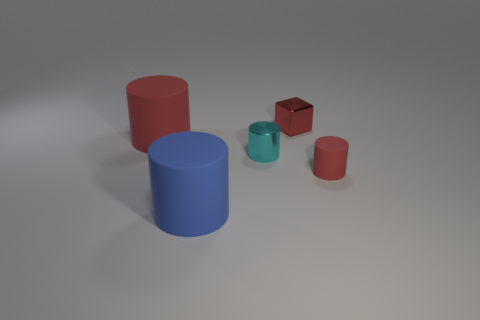What number of objects are either tiny cylinders that are to the right of the shiny block or small green objects?
Provide a succinct answer. 1. Is the number of large rubber objects that are behind the blue cylinder greater than the number of cyan shiny cylinders that are behind the metallic cylinder?
Provide a succinct answer. Yes. There is a matte cylinder that is the same color as the tiny matte thing; what is its size?
Provide a short and direct response. Large. There is a cube; is it the same size as the red thing right of the small red block?
Offer a very short reply. Yes. How many cylinders are either blue rubber objects or small objects?
Give a very brief answer. 3. What is the size of the red block that is made of the same material as the cyan cylinder?
Make the answer very short. Small. There is a red rubber cylinder on the right side of the blue rubber cylinder; does it have the same size as the red matte cylinder to the left of the small red metal object?
Make the answer very short. No. What number of objects are tiny rubber cylinders or blue matte objects?
Ensure brevity in your answer.  2. What is the shape of the red metallic object?
Your answer should be very brief. Cube. The other red matte object that is the same shape as the large red rubber thing is what size?
Your response must be concise. Small. 